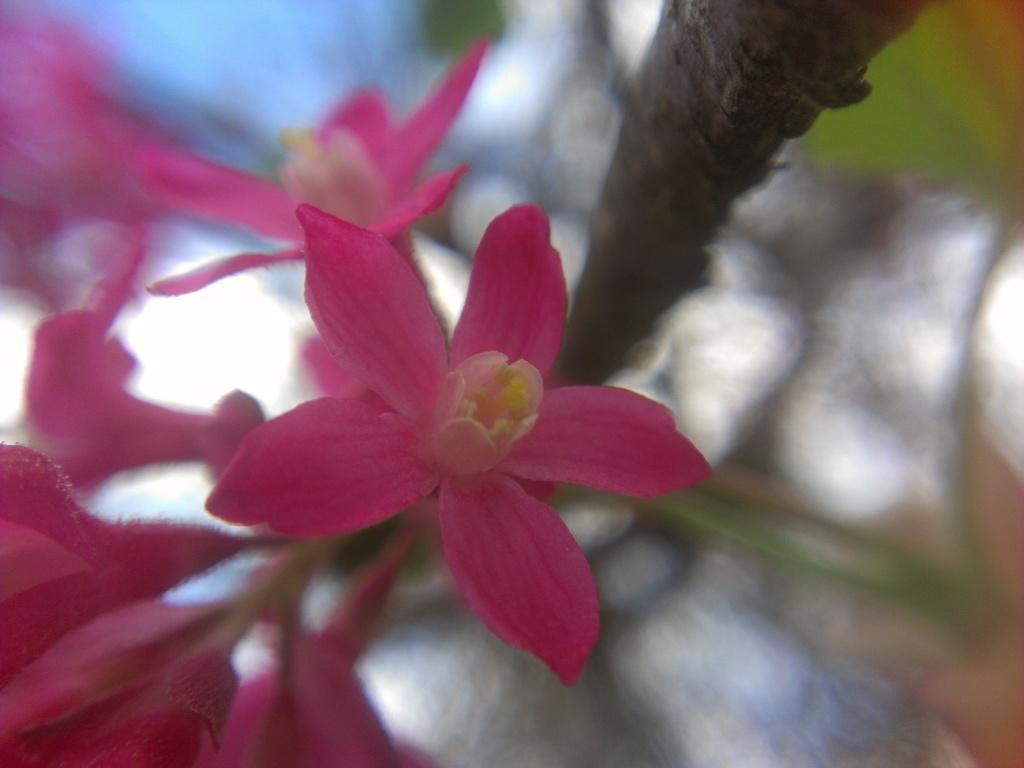How would you summarize this image in a sentence or two? This image is taken outdoors. In this image there is a plant. On the left side of the image there are a few flowers which are pink in color. 